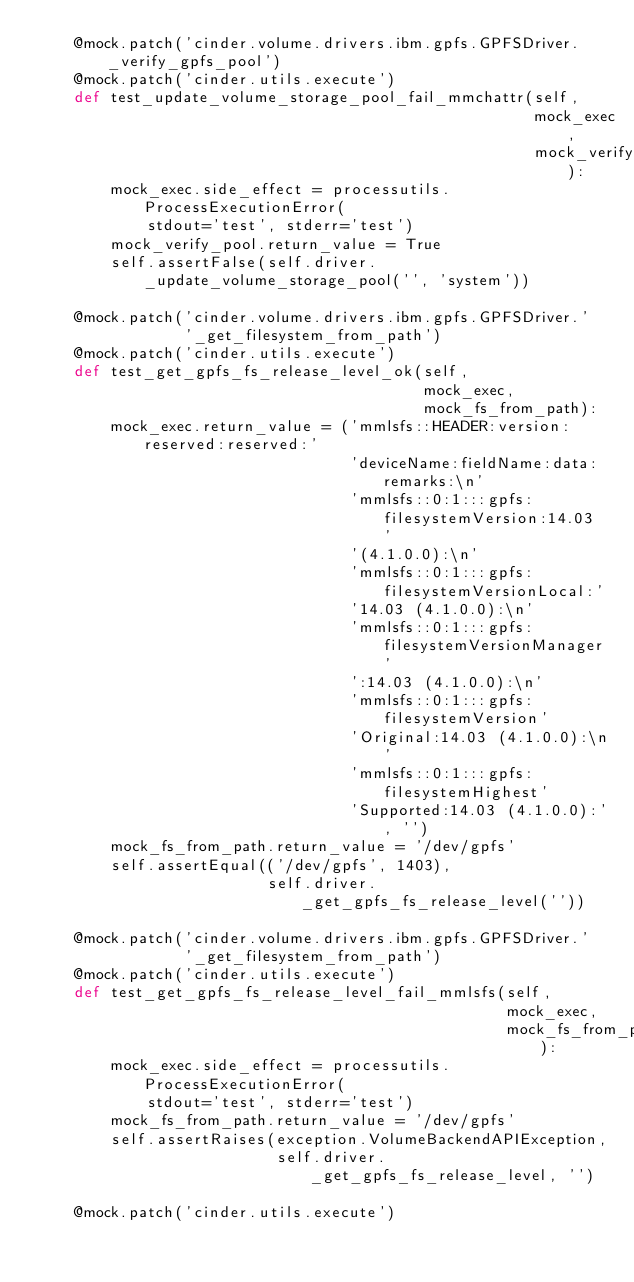<code> <loc_0><loc_0><loc_500><loc_500><_Python_>    @mock.patch('cinder.volume.drivers.ibm.gpfs.GPFSDriver._verify_gpfs_pool')
    @mock.patch('cinder.utils.execute')
    def test_update_volume_storage_pool_fail_mmchattr(self,
                                                      mock_exec,
                                                      mock_verify_pool):
        mock_exec.side_effect = processutils.ProcessExecutionError(
            stdout='test', stderr='test')
        mock_verify_pool.return_value = True
        self.assertFalse(self.driver._update_volume_storage_pool('', 'system'))

    @mock.patch('cinder.volume.drivers.ibm.gpfs.GPFSDriver.'
                '_get_filesystem_from_path')
    @mock.patch('cinder.utils.execute')
    def test_get_gpfs_fs_release_level_ok(self,
                                          mock_exec,
                                          mock_fs_from_path):
        mock_exec.return_value = ('mmlsfs::HEADER:version:reserved:reserved:'
                                  'deviceName:fieldName:data:remarks:\n'
                                  'mmlsfs::0:1:::gpfs:filesystemVersion:14.03 '
                                  '(4.1.0.0):\n'
                                  'mmlsfs::0:1:::gpfs:filesystemVersionLocal:'
                                  '14.03 (4.1.0.0):\n'
                                  'mmlsfs::0:1:::gpfs:filesystemVersionManager'
                                  ':14.03 (4.1.0.0):\n'
                                  'mmlsfs::0:1:::gpfs:filesystemVersion'
                                  'Original:14.03 (4.1.0.0):\n'
                                  'mmlsfs::0:1:::gpfs:filesystemHighest'
                                  'Supported:14.03 (4.1.0.0):', '')
        mock_fs_from_path.return_value = '/dev/gpfs'
        self.assertEqual(('/dev/gpfs', 1403),
                         self.driver._get_gpfs_fs_release_level(''))

    @mock.patch('cinder.volume.drivers.ibm.gpfs.GPFSDriver.'
                '_get_filesystem_from_path')
    @mock.patch('cinder.utils.execute')
    def test_get_gpfs_fs_release_level_fail_mmlsfs(self,
                                                   mock_exec,
                                                   mock_fs_from_path):
        mock_exec.side_effect = processutils.ProcessExecutionError(
            stdout='test', stderr='test')
        mock_fs_from_path.return_value = '/dev/gpfs'
        self.assertRaises(exception.VolumeBackendAPIException,
                          self.driver._get_gpfs_fs_release_level, '')

    @mock.patch('cinder.utils.execute')</code> 